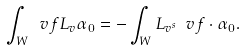Convert formula to latex. <formula><loc_0><loc_0><loc_500><loc_500>\int _ { W } \ v f L _ { v } \alpha _ { 0 } = - \int _ { W } L _ { v ^ { s } } \ v f \cdot \alpha _ { 0 } .</formula> 